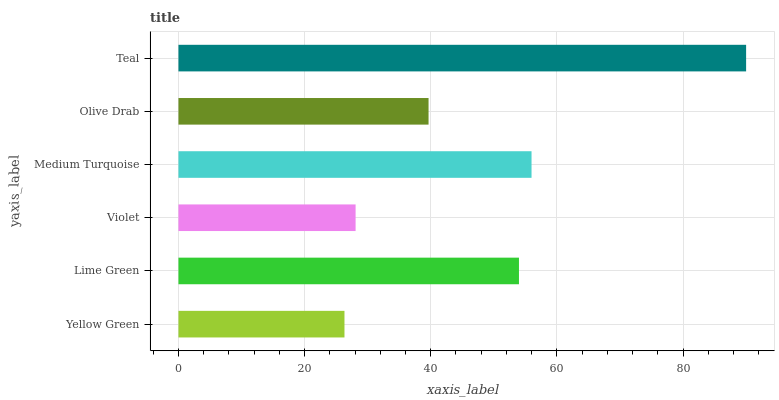Is Yellow Green the minimum?
Answer yes or no. Yes. Is Teal the maximum?
Answer yes or no. Yes. Is Lime Green the minimum?
Answer yes or no. No. Is Lime Green the maximum?
Answer yes or no. No. Is Lime Green greater than Yellow Green?
Answer yes or no. Yes. Is Yellow Green less than Lime Green?
Answer yes or no. Yes. Is Yellow Green greater than Lime Green?
Answer yes or no. No. Is Lime Green less than Yellow Green?
Answer yes or no. No. Is Lime Green the high median?
Answer yes or no. Yes. Is Olive Drab the low median?
Answer yes or no. Yes. Is Teal the high median?
Answer yes or no. No. Is Lime Green the low median?
Answer yes or no. No. 